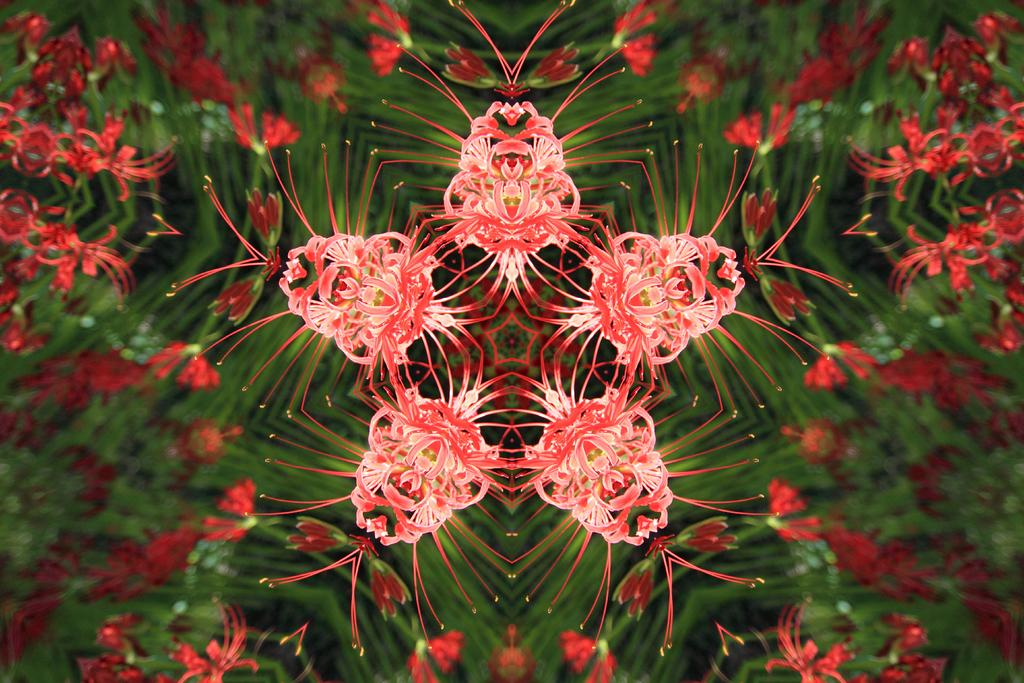What type of plant is visible in the image? There is a plant with a flower in the image. How is the plant supported or displayed in the image? The plant is placed on a glass. What other objects or elements can be seen in the image? There are five time images in the image. What type of spark can be seen coming from the plant in the image? There is no spark visible in the image. 